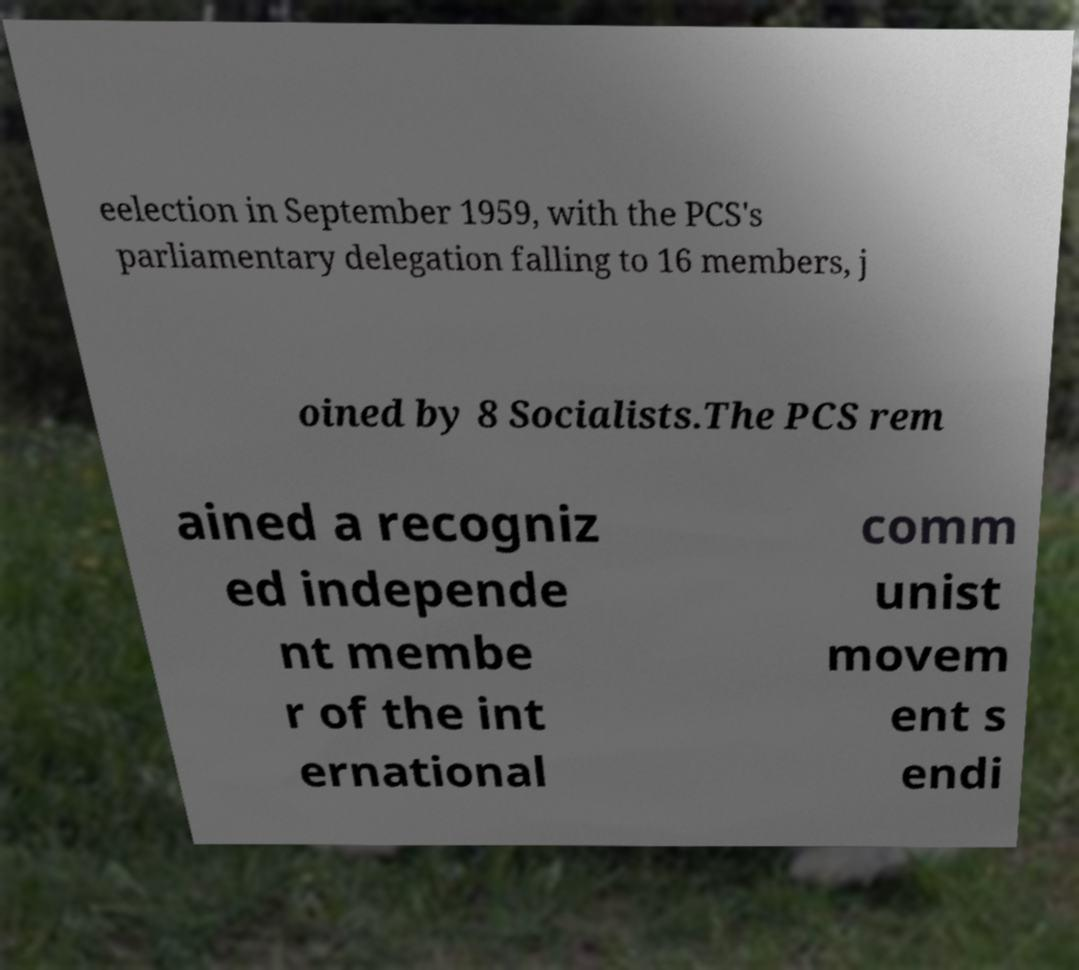Could you assist in decoding the text presented in this image and type it out clearly? eelection in September 1959, with the PCS's parliamentary delegation falling to 16 members, j oined by 8 Socialists.The PCS rem ained a recogniz ed independe nt membe r of the int ernational comm unist movem ent s endi 